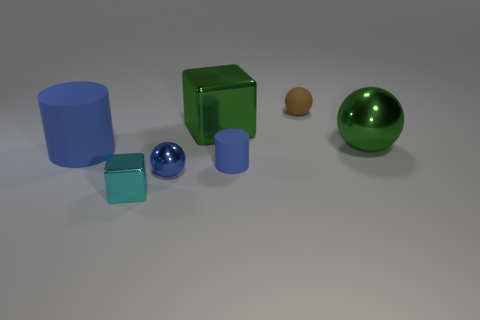Add 3 gray rubber blocks. How many objects exist? 10 Subtract all spheres. How many objects are left? 4 Subtract 0 brown blocks. How many objects are left? 7 Subtract all purple rubber blocks. Subtract all small brown rubber balls. How many objects are left? 6 Add 4 large spheres. How many large spheres are left? 5 Add 5 small blue cylinders. How many small blue cylinders exist? 6 